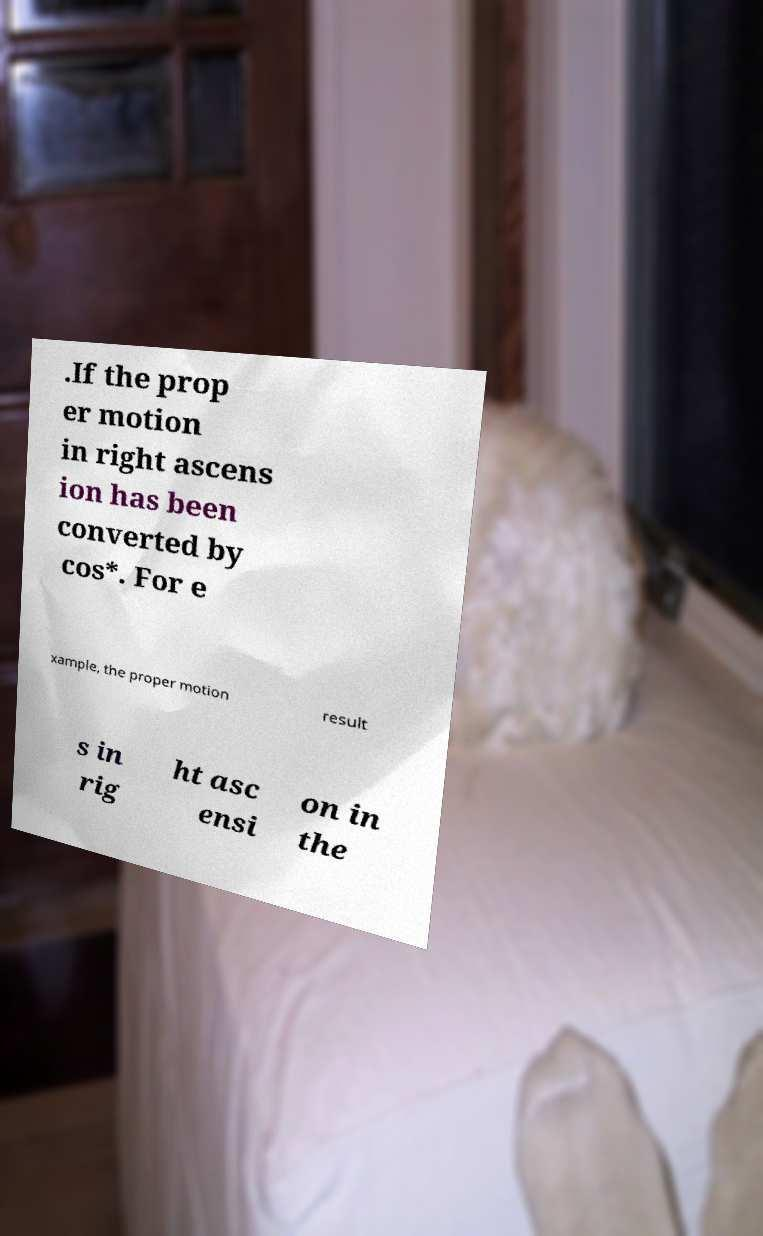Can you accurately transcribe the text from the provided image for me? .If the prop er motion in right ascens ion has been converted by cos*. For e xample, the proper motion result s in rig ht asc ensi on in the 